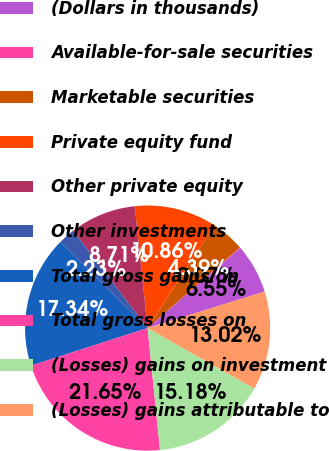Convert chart to OTSL. <chart><loc_0><loc_0><loc_500><loc_500><pie_chart><fcel>(Dollars in thousands)<fcel>Available-for-sale securities<fcel>Marketable securities<fcel>Private equity fund<fcel>Other private equity<fcel>Other investments<fcel>Total gross gains on<fcel>Total gross losses on<fcel>(Losses) gains on investment<fcel>(Losses) gains attributable to<nl><fcel>6.55%<fcel>0.07%<fcel>4.39%<fcel>10.86%<fcel>8.71%<fcel>2.23%<fcel>17.34%<fcel>21.65%<fcel>15.18%<fcel>13.02%<nl></chart> 